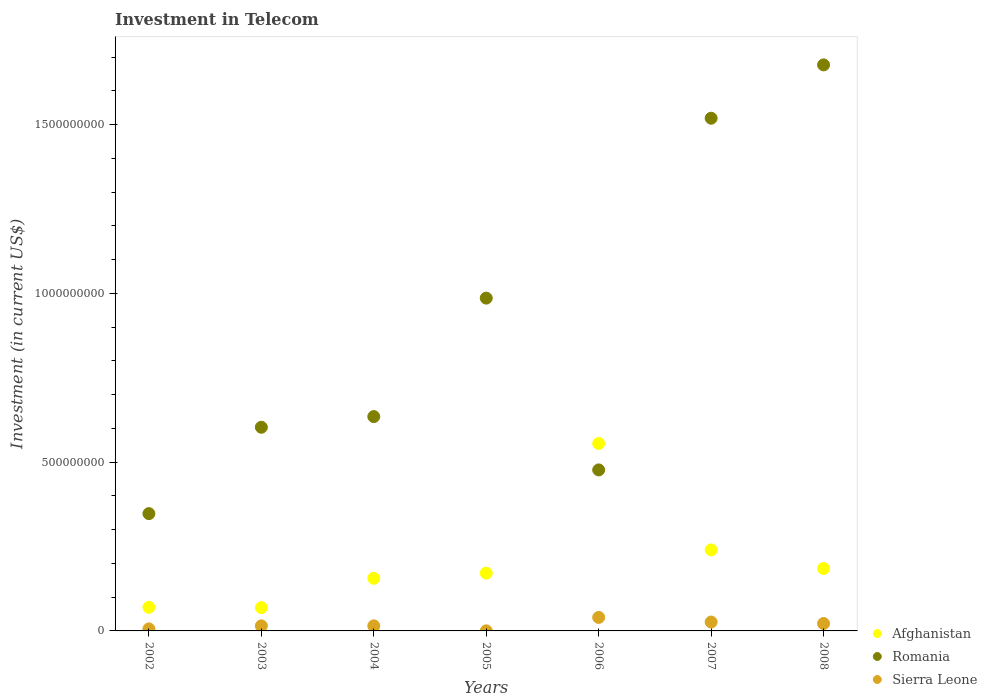Is the number of dotlines equal to the number of legend labels?
Your answer should be very brief. Yes. What is the amount invested in telecom in Sierra Leone in 2007?
Provide a succinct answer. 2.63e+07. Across all years, what is the maximum amount invested in telecom in Afghanistan?
Provide a succinct answer. 5.55e+08. In which year was the amount invested in telecom in Romania maximum?
Give a very brief answer. 2008. In which year was the amount invested in telecom in Afghanistan minimum?
Make the answer very short. 2003. What is the total amount invested in telecom in Romania in the graph?
Offer a terse response. 6.24e+09. What is the difference between the amount invested in telecom in Romania in 2004 and that in 2005?
Keep it short and to the point. -3.51e+08. What is the difference between the amount invested in telecom in Afghanistan in 2003 and the amount invested in telecom in Sierra Leone in 2005?
Keep it short and to the point. 6.88e+07. What is the average amount invested in telecom in Afghanistan per year?
Your answer should be compact. 2.07e+08. In the year 2006, what is the difference between the amount invested in telecom in Romania and amount invested in telecom in Sierra Leone?
Offer a terse response. 4.37e+08. What is the ratio of the amount invested in telecom in Sierra Leone in 2005 to that in 2008?
Your answer should be very brief. 0.01. Is the amount invested in telecom in Romania in 2006 less than that in 2008?
Your answer should be compact. Yes. Is the difference between the amount invested in telecom in Romania in 2002 and 2005 greater than the difference between the amount invested in telecom in Sierra Leone in 2002 and 2005?
Offer a very short reply. No. What is the difference between the highest and the second highest amount invested in telecom in Romania?
Provide a succinct answer. 1.58e+08. What is the difference between the highest and the lowest amount invested in telecom in Sierra Leone?
Ensure brevity in your answer.  3.98e+07. Is the amount invested in telecom in Romania strictly greater than the amount invested in telecom in Sierra Leone over the years?
Your answer should be very brief. Yes. Is the amount invested in telecom in Romania strictly less than the amount invested in telecom in Afghanistan over the years?
Keep it short and to the point. No. Are the values on the major ticks of Y-axis written in scientific E-notation?
Your response must be concise. No. Does the graph contain any zero values?
Offer a very short reply. No. Does the graph contain grids?
Provide a short and direct response. No. How many legend labels are there?
Make the answer very short. 3. How are the legend labels stacked?
Make the answer very short. Vertical. What is the title of the graph?
Offer a terse response. Investment in Telecom. Does "Swaziland" appear as one of the legend labels in the graph?
Your answer should be very brief. No. What is the label or title of the Y-axis?
Offer a very short reply. Investment (in current US$). What is the Investment (in current US$) of Afghanistan in 2002?
Provide a short and direct response. 7.00e+07. What is the Investment (in current US$) of Romania in 2002?
Offer a terse response. 3.48e+08. What is the Investment (in current US$) of Afghanistan in 2003?
Your response must be concise. 6.90e+07. What is the Investment (in current US$) in Romania in 2003?
Give a very brief answer. 6.03e+08. What is the Investment (in current US$) of Sierra Leone in 2003?
Offer a very short reply. 1.50e+07. What is the Investment (in current US$) in Afghanistan in 2004?
Give a very brief answer. 1.56e+08. What is the Investment (in current US$) of Romania in 2004?
Provide a succinct answer. 6.35e+08. What is the Investment (in current US$) in Sierra Leone in 2004?
Ensure brevity in your answer.  1.50e+07. What is the Investment (in current US$) of Afghanistan in 2005?
Your answer should be compact. 1.71e+08. What is the Investment (in current US$) of Romania in 2005?
Ensure brevity in your answer.  9.86e+08. What is the Investment (in current US$) in Afghanistan in 2006?
Provide a succinct answer. 5.55e+08. What is the Investment (in current US$) of Romania in 2006?
Make the answer very short. 4.77e+08. What is the Investment (in current US$) of Sierra Leone in 2006?
Make the answer very short. 4.00e+07. What is the Investment (in current US$) of Afghanistan in 2007?
Offer a very short reply. 2.40e+08. What is the Investment (in current US$) of Romania in 2007?
Make the answer very short. 1.52e+09. What is the Investment (in current US$) of Sierra Leone in 2007?
Ensure brevity in your answer.  2.63e+07. What is the Investment (in current US$) in Afghanistan in 2008?
Your answer should be very brief. 1.85e+08. What is the Investment (in current US$) of Romania in 2008?
Your answer should be very brief. 1.68e+09. What is the Investment (in current US$) in Sierra Leone in 2008?
Your answer should be compact. 2.19e+07. Across all years, what is the maximum Investment (in current US$) of Afghanistan?
Provide a short and direct response. 5.55e+08. Across all years, what is the maximum Investment (in current US$) in Romania?
Give a very brief answer. 1.68e+09. Across all years, what is the maximum Investment (in current US$) of Sierra Leone?
Ensure brevity in your answer.  4.00e+07. Across all years, what is the minimum Investment (in current US$) of Afghanistan?
Provide a succinct answer. 6.90e+07. Across all years, what is the minimum Investment (in current US$) of Romania?
Make the answer very short. 3.48e+08. Across all years, what is the minimum Investment (in current US$) of Sierra Leone?
Offer a very short reply. 2.50e+05. What is the total Investment (in current US$) in Afghanistan in the graph?
Keep it short and to the point. 1.45e+09. What is the total Investment (in current US$) in Romania in the graph?
Your answer should be very brief. 6.24e+09. What is the total Investment (in current US$) in Sierra Leone in the graph?
Keep it short and to the point. 1.24e+08. What is the difference between the Investment (in current US$) in Romania in 2002 and that in 2003?
Your response must be concise. -2.56e+08. What is the difference between the Investment (in current US$) of Sierra Leone in 2002 and that in 2003?
Keep it short and to the point. -9.00e+06. What is the difference between the Investment (in current US$) in Afghanistan in 2002 and that in 2004?
Keep it short and to the point. -8.60e+07. What is the difference between the Investment (in current US$) in Romania in 2002 and that in 2004?
Ensure brevity in your answer.  -2.88e+08. What is the difference between the Investment (in current US$) of Sierra Leone in 2002 and that in 2004?
Keep it short and to the point. -9.00e+06. What is the difference between the Investment (in current US$) in Afghanistan in 2002 and that in 2005?
Ensure brevity in your answer.  -1.01e+08. What is the difference between the Investment (in current US$) in Romania in 2002 and that in 2005?
Offer a very short reply. -6.38e+08. What is the difference between the Investment (in current US$) in Sierra Leone in 2002 and that in 2005?
Offer a terse response. 5.75e+06. What is the difference between the Investment (in current US$) in Afghanistan in 2002 and that in 2006?
Provide a short and direct response. -4.85e+08. What is the difference between the Investment (in current US$) of Romania in 2002 and that in 2006?
Provide a short and direct response. -1.30e+08. What is the difference between the Investment (in current US$) in Sierra Leone in 2002 and that in 2006?
Your answer should be very brief. -3.40e+07. What is the difference between the Investment (in current US$) in Afghanistan in 2002 and that in 2007?
Provide a succinct answer. -1.70e+08. What is the difference between the Investment (in current US$) in Romania in 2002 and that in 2007?
Provide a short and direct response. -1.17e+09. What is the difference between the Investment (in current US$) of Sierra Leone in 2002 and that in 2007?
Your response must be concise. -2.03e+07. What is the difference between the Investment (in current US$) of Afghanistan in 2002 and that in 2008?
Make the answer very short. -1.15e+08. What is the difference between the Investment (in current US$) of Romania in 2002 and that in 2008?
Keep it short and to the point. -1.33e+09. What is the difference between the Investment (in current US$) in Sierra Leone in 2002 and that in 2008?
Keep it short and to the point. -1.59e+07. What is the difference between the Investment (in current US$) of Afghanistan in 2003 and that in 2004?
Give a very brief answer. -8.70e+07. What is the difference between the Investment (in current US$) in Romania in 2003 and that in 2004?
Provide a succinct answer. -3.16e+07. What is the difference between the Investment (in current US$) in Afghanistan in 2003 and that in 2005?
Offer a very short reply. -1.02e+08. What is the difference between the Investment (in current US$) in Romania in 2003 and that in 2005?
Provide a short and direct response. -3.83e+08. What is the difference between the Investment (in current US$) of Sierra Leone in 2003 and that in 2005?
Make the answer very short. 1.48e+07. What is the difference between the Investment (in current US$) of Afghanistan in 2003 and that in 2006?
Provide a succinct answer. -4.86e+08. What is the difference between the Investment (in current US$) of Romania in 2003 and that in 2006?
Offer a very short reply. 1.26e+08. What is the difference between the Investment (in current US$) of Sierra Leone in 2003 and that in 2006?
Provide a short and direct response. -2.50e+07. What is the difference between the Investment (in current US$) of Afghanistan in 2003 and that in 2007?
Provide a succinct answer. -1.71e+08. What is the difference between the Investment (in current US$) of Romania in 2003 and that in 2007?
Keep it short and to the point. -9.16e+08. What is the difference between the Investment (in current US$) in Sierra Leone in 2003 and that in 2007?
Ensure brevity in your answer.  -1.13e+07. What is the difference between the Investment (in current US$) of Afghanistan in 2003 and that in 2008?
Provide a short and direct response. -1.16e+08. What is the difference between the Investment (in current US$) in Romania in 2003 and that in 2008?
Your answer should be compact. -1.07e+09. What is the difference between the Investment (in current US$) in Sierra Leone in 2003 and that in 2008?
Provide a succinct answer. -6.90e+06. What is the difference between the Investment (in current US$) of Afghanistan in 2004 and that in 2005?
Provide a short and direct response. -1.51e+07. What is the difference between the Investment (in current US$) in Romania in 2004 and that in 2005?
Keep it short and to the point. -3.51e+08. What is the difference between the Investment (in current US$) in Sierra Leone in 2004 and that in 2005?
Give a very brief answer. 1.48e+07. What is the difference between the Investment (in current US$) of Afghanistan in 2004 and that in 2006?
Make the answer very short. -3.99e+08. What is the difference between the Investment (in current US$) of Romania in 2004 and that in 2006?
Your response must be concise. 1.58e+08. What is the difference between the Investment (in current US$) in Sierra Leone in 2004 and that in 2006?
Your answer should be very brief. -2.50e+07. What is the difference between the Investment (in current US$) in Afghanistan in 2004 and that in 2007?
Ensure brevity in your answer.  -8.40e+07. What is the difference between the Investment (in current US$) of Romania in 2004 and that in 2007?
Ensure brevity in your answer.  -8.84e+08. What is the difference between the Investment (in current US$) of Sierra Leone in 2004 and that in 2007?
Offer a terse response. -1.13e+07. What is the difference between the Investment (in current US$) in Afghanistan in 2004 and that in 2008?
Give a very brief answer. -2.90e+07. What is the difference between the Investment (in current US$) in Romania in 2004 and that in 2008?
Ensure brevity in your answer.  -1.04e+09. What is the difference between the Investment (in current US$) in Sierra Leone in 2004 and that in 2008?
Your answer should be very brief. -6.90e+06. What is the difference between the Investment (in current US$) in Afghanistan in 2005 and that in 2006?
Your answer should be compact. -3.84e+08. What is the difference between the Investment (in current US$) of Romania in 2005 and that in 2006?
Ensure brevity in your answer.  5.09e+08. What is the difference between the Investment (in current US$) in Sierra Leone in 2005 and that in 2006?
Keep it short and to the point. -3.98e+07. What is the difference between the Investment (in current US$) in Afghanistan in 2005 and that in 2007?
Give a very brief answer. -6.89e+07. What is the difference between the Investment (in current US$) of Romania in 2005 and that in 2007?
Keep it short and to the point. -5.33e+08. What is the difference between the Investment (in current US$) in Sierra Leone in 2005 and that in 2007?
Keep it short and to the point. -2.60e+07. What is the difference between the Investment (in current US$) in Afghanistan in 2005 and that in 2008?
Your response must be concise. -1.39e+07. What is the difference between the Investment (in current US$) of Romania in 2005 and that in 2008?
Make the answer very short. -6.91e+08. What is the difference between the Investment (in current US$) in Sierra Leone in 2005 and that in 2008?
Provide a succinct answer. -2.16e+07. What is the difference between the Investment (in current US$) in Afghanistan in 2006 and that in 2007?
Keep it short and to the point. 3.15e+08. What is the difference between the Investment (in current US$) of Romania in 2006 and that in 2007?
Offer a very short reply. -1.04e+09. What is the difference between the Investment (in current US$) in Sierra Leone in 2006 and that in 2007?
Your response must be concise. 1.37e+07. What is the difference between the Investment (in current US$) of Afghanistan in 2006 and that in 2008?
Offer a very short reply. 3.70e+08. What is the difference between the Investment (in current US$) in Romania in 2006 and that in 2008?
Offer a terse response. -1.20e+09. What is the difference between the Investment (in current US$) in Sierra Leone in 2006 and that in 2008?
Give a very brief answer. 1.81e+07. What is the difference between the Investment (in current US$) of Afghanistan in 2007 and that in 2008?
Your response must be concise. 5.50e+07. What is the difference between the Investment (in current US$) of Romania in 2007 and that in 2008?
Offer a very short reply. -1.58e+08. What is the difference between the Investment (in current US$) of Sierra Leone in 2007 and that in 2008?
Give a very brief answer. 4.40e+06. What is the difference between the Investment (in current US$) in Afghanistan in 2002 and the Investment (in current US$) in Romania in 2003?
Make the answer very short. -5.33e+08. What is the difference between the Investment (in current US$) in Afghanistan in 2002 and the Investment (in current US$) in Sierra Leone in 2003?
Offer a very short reply. 5.50e+07. What is the difference between the Investment (in current US$) in Romania in 2002 and the Investment (in current US$) in Sierra Leone in 2003?
Provide a short and direct response. 3.32e+08. What is the difference between the Investment (in current US$) in Afghanistan in 2002 and the Investment (in current US$) in Romania in 2004?
Your answer should be very brief. -5.65e+08. What is the difference between the Investment (in current US$) in Afghanistan in 2002 and the Investment (in current US$) in Sierra Leone in 2004?
Offer a very short reply. 5.50e+07. What is the difference between the Investment (in current US$) in Romania in 2002 and the Investment (in current US$) in Sierra Leone in 2004?
Offer a terse response. 3.32e+08. What is the difference between the Investment (in current US$) in Afghanistan in 2002 and the Investment (in current US$) in Romania in 2005?
Your answer should be compact. -9.16e+08. What is the difference between the Investment (in current US$) of Afghanistan in 2002 and the Investment (in current US$) of Sierra Leone in 2005?
Make the answer very short. 6.98e+07. What is the difference between the Investment (in current US$) of Romania in 2002 and the Investment (in current US$) of Sierra Leone in 2005?
Offer a very short reply. 3.47e+08. What is the difference between the Investment (in current US$) in Afghanistan in 2002 and the Investment (in current US$) in Romania in 2006?
Ensure brevity in your answer.  -4.07e+08. What is the difference between the Investment (in current US$) in Afghanistan in 2002 and the Investment (in current US$) in Sierra Leone in 2006?
Your answer should be very brief. 3.00e+07. What is the difference between the Investment (in current US$) in Romania in 2002 and the Investment (in current US$) in Sierra Leone in 2006?
Your answer should be very brief. 3.08e+08. What is the difference between the Investment (in current US$) of Afghanistan in 2002 and the Investment (in current US$) of Romania in 2007?
Ensure brevity in your answer.  -1.45e+09. What is the difference between the Investment (in current US$) in Afghanistan in 2002 and the Investment (in current US$) in Sierra Leone in 2007?
Provide a short and direct response. 4.37e+07. What is the difference between the Investment (in current US$) in Romania in 2002 and the Investment (in current US$) in Sierra Leone in 2007?
Provide a short and direct response. 3.21e+08. What is the difference between the Investment (in current US$) in Afghanistan in 2002 and the Investment (in current US$) in Romania in 2008?
Your response must be concise. -1.61e+09. What is the difference between the Investment (in current US$) in Afghanistan in 2002 and the Investment (in current US$) in Sierra Leone in 2008?
Give a very brief answer. 4.81e+07. What is the difference between the Investment (in current US$) of Romania in 2002 and the Investment (in current US$) of Sierra Leone in 2008?
Provide a succinct answer. 3.26e+08. What is the difference between the Investment (in current US$) in Afghanistan in 2003 and the Investment (in current US$) in Romania in 2004?
Your response must be concise. -5.66e+08. What is the difference between the Investment (in current US$) in Afghanistan in 2003 and the Investment (in current US$) in Sierra Leone in 2004?
Keep it short and to the point. 5.40e+07. What is the difference between the Investment (in current US$) in Romania in 2003 and the Investment (in current US$) in Sierra Leone in 2004?
Your answer should be compact. 5.88e+08. What is the difference between the Investment (in current US$) in Afghanistan in 2003 and the Investment (in current US$) in Romania in 2005?
Make the answer very short. -9.17e+08. What is the difference between the Investment (in current US$) in Afghanistan in 2003 and the Investment (in current US$) in Sierra Leone in 2005?
Ensure brevity in your answer.  6.88e+07. What is the difference between the Investment (in current US$) of Romania in 2003 and the Investment (in current US$) of Sierra Leone in 2005?
Provide a succinct answer. 6.03e+08. What is the difference between the Investment (in current US$) of Afghanistan in 2003 and the Investment (in current US$) of Romania in 2006?
Offer a very short reply. -4.08e+08. What is the difference between the Investment (in current US$) of Afghanistan in 2003 and the Investment (in current US$) of Sierra Leone in 2006?
Your response must be concise. 2.90e+07. What is the difference between the Investment (in current US$) of Romania in 2003 and the Investment (in current US$) of Sierra Leone in 2006?
Make the answer very short. 5.63e+08. What is the difference between the Investment (in current US$) of Afghanistan in 2003 and the Investment (in current US$) of Romania in 2007?
Provide a short and direct response. -1.45e+09. What is the difference between the Investment (in current US$) of Afghanistan in 2003 and the Investment (in current US$) of Sierra Leone in 2007?
Your answer should be compact. 4.27e+07. What is the difference between the Investment (in current US$) of Romania in 2003 and the Investment (in current US$) of Sierra Leone in 2007?
Your response must be concise. 5.77e+08. What is the difference between the Investment (in current US$) of Afghanistan in 2003 and the Investment (in current US$) of Romania in 2008?
Offer a very short reply. -1.61e+09. What is the difference between the Investment (in current US$) in Afghanistan in 2003 and the Investment (in current US$) in Sierra Leone in 2008?
Offer a very short reply. 4.71e+07. What is the difference between the Investment (in current US$) of Romania in 2003 and the Investment (in current US$) of Sierra Leone in 2008?
Your answer should be very brief. 5.82e+08. What is the difference between the Investment (in current US$) in Afghanistan in 2004 and the Investment (in current US$) in Romania in 2005?
Your answer should be very brief. -8.30e+08. What is the difference between the Investment (in current US$) in Afghanistan in 2004 and the Investment (in current US$) in Sierra Leone in 2005?
Offer a very short reply. 1.56e+08. What is the difference between the Investment (in current US$) in Romania in 2004 and the Investment (in current US$) in Sierra Leone in 2005?
Make the answer very short. 6.35e+08. What is the difference between the Investment (in current US$) of Afghanistan in 2004 and the Investment (in current US$) of Romania in 2006?
Offer a very short reply. -3.21e+08. What is the difference between the Investment (in current US$) in Afghanistan in 2004 and the Investment (in current US$) in Sierra Leone in 2006?
Your answer should be compact. 1.16e+08. What is the difference between the Investment (in current US$) in Romania in 2004 and the Investment (in current US$) in Sierra Leone in 2006?
Offer a very short reply. 5.95e+08. What is the difference between the Investment (in current US$) of Afghanistan in 2004 and the Investment (in current US$) of Romania in 2007?
Your response must be concise. -1.36e+09. What is the difference between the Investment (in current US$) of Afghanistan in 2004 and the Investment (in current US$) of Sierra Leone in 2007?
Make the answer very short. 1.30e+08. What is the difference between the Investment (in current US$) of Romania in 2004 and the Investment (in current US$) of Sierra Leone in 2007?
Your answer should be compact. 6.09e+08. What is the difference between the Investment (in current US$) in Afghanistan in 2004 and the Investment (in current US$) in Romania in 2008?
Make the answer very short. -1.52e+09. What is the difference between the Investment (in current US$) of Afghanistan in 2004 and the Investment (in current US$) of Sierra Leone in 2008?
Offer a very short reply. 1.34e+08. What is the difference between the Investment (in current US$) of Romania in 2004 and the Investment (in current US$) of Sierra Leone in 2008?
Keep it short and to the point. 6.13e+08. What is the difference between the Investment (in current US$) of Afghanistan in 2005 and the Investment (in current US$) of Romania in 2006?
Ensure brevity in your answer.  -3.06e+08. What is the difference between the Investment (in current US$) in Afghanistan in 2005 and the Investment (in current US$) in Sierra Leone in 2006?
Provide a succinct answer. 1.31e+08. What is the difference between the Investment (in current US$) of Romania in 2005 and the Investment (in current US$) of Sierra Leone in 2006?
Provide a short and direct response. 9.46e+08. What is the difference between the Investment (in current US$) in Afghanistan in 2005 and the Investment (in current US$) in Romania in 2007?
Offer a terse response. -1.35e+09. What is the difference between the Investment (in current US$) in Afghanistan in 2005 and the Investment (in current US$) in Sierra Leone in 2007?
Provide a short and direct response. 1.45e+08. What is the difference between the Investment (in current US$) of Romania in 2005 and the Investment (in current US$) of Sierra Leone in 2007?
Offer a very short reply. 9.60e+08. What is the difference between the Investment (in current US$) of Afghanistan in 2005 and the Investment (in current US$) of Romania in 2008?
Offer a terse response. -1.51e+09. What is the difference between the Investment (in current US$) of Afghanistan in 2005 and the Investment (in current US$) of Sierra Leone in 2008?
Offer a very short reply. 1.49e+08. What is the difference between the Investment (in current US$) in Romania in 2005 and the Investment (in current US$) in Sierra Leone in 2008?
Keep it short and to the point. 9.64e+08. What is the difference between the Investment (in current US$) of Afghanistan in 2006 and the Investment (in current US$) of Romania in 2007?
Offer a very short reply. -9.64e+08. What is the difference between the Investment (in current US$) of Afghanistan in 2006 and the Investment (in current US$) of Sierra Leone in 2007?
Offer a terse response. 5.29e+08. What is the difference between the Investment (in current US$) in Romania in 2006 and the Investment (in current US$) in Sierra Leone in 2007?
Your response must be concise. 4.51e+08. What is the difference between the Investment (in current US$) of Afghanistan in 2006 and the Investment (in current US$) of Romania in 2008?
Your response must be concise. -1.12e+09. What is the difference between the Investment (in current US$) of Afghanistan in 2006 and the Investment (in current US$) of Sierra Leone in 2008?
Ensure brevity in your answer.  5.34e+08. What is the difference between the Investment (in current US$) of Romania in 2006 and the Investment (in current US$) of Sierra Leone in 2008?
Provide a short and direct response. 4.55e+08. What is the difference between the Investment (in current US$) in Afghanistan in 2007 and the Investment (in current US$) in Romania in 2008?
Make the answer very short. -1.44e+09. What is the difference between the Investment (in current US$) in Afghanistan in 2007 and the Investment (in current US$) in Sierra Leone in 2008?
Provide a short and direct response. 2.18e+08. What is the difference between the Investment (in current US$) in Romania in 2007 and the Investment (in current US$) in Sierra Leone in 2008?
Your answer should be compact. 1.50e+09. What is the average Investment (in current US$) of Afghanistan per year?
Provide a succinct answer. 2.07e+08. What is the average Investment (in current US$) in Romania per year?
Give a very brief answer. 8.92e+08. What is the average Investment (in current US$) in Sierra Leone per year?
Ensure brevity in your answer.  1.78e+07. In the year 2002, what is the difference between the Investment (in current US$) of Afghanistan and Investment (in current US$) of Romania?
Your response must be concise. -2.78e+08. In the year 2002, what is the difference between the Investment (in current US$) of Afghanistan and Investment (in current US$) of Sierra Leone?
Make the answer very short. 6.40e+07. In the year 2002, what is the difference between the Investment (in current US$) in Romania and Investment (in current US$) in Sierra Leone?
Make the answer very short. 3.42e+08. In the year 2003, what is the difference between the Investment (in current US$) of Afghanistan and Investment (in current US$) of Romania?
Provide a short and direct response. -5.34e+08. In the year 2003, what is the difference between the Investment (in current US$) in Afghanistan and Investment (in current US$) in Sierra Leone?
Offer a very short reply. 5.40e+07. In the year 2003, what is the difference between the Investment (in current US$) of Romania and Investment (in current US$) of Sierra Leone?
Provide a succinct answer. 5.88e+08. In the year 2004, what is the difference between the Investment (in current US$) in Afghanistan and Investment (in current US$) in Romania?
Keep it short and to the point. -4.79e+08. In the year 2004, what is the difference between the Investment (in current US$) of Afghanistan and Investment (in current US$) of Sierra Leone?
Offer a very short reply. 1.41e+08. In the year 2004, what is the difference between the Investment (in current US$) of Romania and Investment (in current US$) of Sierra Leone?
Give a very brief answer. 6.20e+08. In the year 2005, what is the difference between the Investment (in current US$) of Afghanistan and Investment (in current US$) of Romania?
Give a very brief answer. -8.15e+08. In the year 2005, what is the difference between the Investment (in current US$) of Afghanistan and Investment (in current US$) of Sierra Leone?
Provide a succinct answer. 1.71e+08. In the year 2005, what is the difference between the Investment (in current US$) of Romania and Investment (in current US$) of Sierra Leone?
Offer a terse response. 9.86e+08. In the year 2006, what is the difference between the Investment (in current US$) of Afghanistan and Investment (in current US$) of Romania?
Keep it short and to the point. 7.84e+07. In the year 2006, what is the difference between the Investment (in current US$) in Afghanistan and Investment (in current US$) in Sierra Leone?
Ensure brevity in your answer.  5.15e+08. In the year 2006, what is the difference between the Investment (in current US$) of Romania and Investment (in current US$) of Sierra Leone?
Your answer should be very brief. 4.37e+08. In the year 2007, what is the difference between the Investment (in current US$) of Afghanistan and Investment (in current US$) of Romania?
Ensure brevity in your answer.  -1.28e+09. In the year 2007, what is the difference between the Investment (in current US$) of Afghanistan and Investment (in current US$) of Sierra Leone?
Your response must be concise. 2.14e+08. In the year 2007, what is the difference between the Investment (in current US$) of Romania and Investment (in current US$) of Sierra Leone?
Your answer should be compact. 1.49e+09. In the year 2008, what is the difference between the Investment (in current US$) of Afghanistan and Investment (in current US$) of Romania?
Ensure brevity in your answer.  -1.49e+09. In the year 2008, what is the difference between the Investment (in current US$) of Afghanistan and Investment (in current US$) of Sierra Leone?
Offer a very short reply. 1.63e+08. In the year 2008, what is the difference between the Investment (in current US$) of Romania and Investment (in current US$) of Sierra Leone?
Offer a very short reply. 1.66e+09. What is the ratio of the Investment (in current US$) of Afghanistan in 2002 to that in 2003?
Provide a short and direct response. 1.01. What is the ratio of the Investment (in current US$) of Romania in 2002 to that in 2003?
Give a very brief answer. 0.58. What is the ratio of the Investment (in current US$) in Afghanistan in 2002 to that in 2004?
Provide a short and direct response. 0.45. What is the ratio of the Investment (in current US$) in Romania in 2002 to that in 2004?
Offer a very short reply. 0.55. What is the ratio of the Investment (in current US$) of Sierra Leone in 2002 to that in 2004?
Offer a very short reply. 0.4. What is the ratio of the Investment (in current US$) in Afghanistan in 2002 to that in 2005?
Your answer should be very brief. 0.41. What is the ratio of the Investment (in current US$) in Romania in 2002 to that in 2005?
Your answer should be compact. 0.35. What is the ratio of the Investment (in current US$) in Sierra Leone in 2002 to that in 2005?
Ensure brevity in your answer.  24. What is the ratio of the Investment (in current US$) in Afghanistan in 2002 to that in 2006?
Your answer should be very brief. 0.13. What is the ratio of the Investment (in current US$) in Romania in 2002 to that in 2006?
Offer a terse response. 0.73. What is the ratio of the Investment (in current US$) in Sierra Leone in 2002 to that in 2006?
Provide a short and direct response. 0.15. What is the ratio of the Investment (in current US$) in Afghanistan in 2002 to that in 2007?
Your response must be concise. 0.29. What is the ratio of the Investment (in current US$) of Romania in 2002 to that in 2007?
Your response must be concise. 0.23. What is the ratio of the Investment (in current US$) of Sierra Leone in 2002 to that in 2007?
Offer a terse response. 0.23. What is the ratio of the Investment (in current US$) in Afghanistan in 2002 to that in 2008?
Your answer should be compact. 0.38. What is the ratio of the Investment (in current US$) of Romania in 2002 to that in 2008?
Your answer should be very brief. 0.21. What is the ratio of the Investment (in current US$) of Sierra Leone in 2002 to that in 2008?
Your answer should be compact. 0.27. What is the ratio of the Investment (in current US$) in Afghanistan in 2003 to that in 2004?
Offer a terse response. 0.44. What is the ratio of the Investment (in current US$) in Romania in 2003 to that in 2004?
Your response must be concise. 0.95. What is the ratio of the Investment (in current US$) of Sierra Leone in 2003 to that in 2004?
Offer a very short reply. 1. What is the ratio of the Investment (in current US$) of Afghanistan in 2003 to that in 2005?
Offer a very short reply. 0.4. What is the ratio of the Investment (in current US$) of Romania in 2003 to that in 2005?
Your answer should be very brief. 0.61. What is the ratio of the Investment (in current US$) of Afghanistan in 2003 to that in 2006?
Provide a short and direct response. 0.12. What is the ratio of the Investment (in current US$) in Romania in 2003 to that in 2006?
Offer a very short reply. 1.26. What is the ratio of the Investment (in current US$) in Afghanistan in 2003 to that in 2007?
Keep it short and to the point. 0.29. What is the ratio of the Investment (in current US$) in Romania in 2003 to that in 2007?
Keep it short and to the point. 0.4. What is the ratio of the Investment (in current US$) in Sierra Leone in 2003 to that in 2007?
Offer a very short reply. 0.57. What is the ratio of the Investment (in current US$) of Afghanistan in 2003 to that in 2008?
Your response must be concise. 0.37. What is the ratio of the Investment (in current US$) of Romania in 2003 to that in 2008?
Your response must be concise. 0.36. What is the ratio of the Investment (in current US$) of Sierra Leone in 2003 to that in 2008?
Ensure brevity in your answer.  0.68. What is the ratio of the Investment (in current US$) in Afghanistan in 2004 to that in 2005?
Keep it short and to the point. 0.91. What is the ratio of the Investment (in current US$) in Romania in 2004 to that in 2005?
Ensure brevity in your answer.  0.64. What is the ratio of the Investment (in current US$) in Sierra Leone in 2004 to that in 2005?
Provide a succinct answer. 60. What is the ratio of the Investment (in current US$) of Afghanistan in 2004 to that in 2006?
Give a very brief answer. 0.28. What is the ratio of the Investment (in current US$) in Romania in 2004 to that in 2006?
Your response must be concise. 1.33. What is the ratio of the Investment (in current US$) in Sierra Leone in 2004 to that in 2006?
Provide a succinct answer. 0.38. What is the ratio of the Investment (in current US$) of Afghanistan in 2004 to that in 2007?
Your answer should be compact. 0.65. What is the ratio of the Investment (in current US$) of Romania in 2004 to that in 2007?
Offer a very short reply. 0.42. What is the ratio of the Investment (in current US$) in Sierra Leone in 2004 to that in 2007?
Ensure brevity in your answer.  0.57. What is the ratio of the Investment (in current US$) of Afghanistan in 2004 to that in 2008?
Ensure brevity in your answer.  0.84. What is the ratio of the Investment (in current US$) of Romania in 2004 to that in 2008?
Provide a succinct answer. 0.38. What is the ratio of the Investment (in current US$) of Sierra Leone in 2004 to that in 2008?
Your response must be concise. 0.68. What is the ratio of the Investment (in current US$) of Afghanistan in 2005 to that in 2006?
Offer a terse response. 0.31. What is the ratio of the Investment (in current US$) of Romania in 2005 to that in 2006?
Keep it short and to the point. 2.07. What is the ratio of the Investment (in current US$) of Sierra Leone in 2005 to that in 2006?
Your answer should be very brief. 0.01. What is the ratio of the Investment (in current US$) in Afghanistan in 2005 to that in 2007?
Ensure brevity in your answer.  0.71. What is the ratio of the Investment (in current US$) in Romania in 2005 to that in 2007?
Your answer should be very brief. 0.65. What is the ratio of the Investment (in current US$) of Sierra Leone in 2005 to that in 2007?
Provide a succinct answer. 0.01. What is the ratio of the Investment (in current US$) of Afghanistan in 2005 to that in 2008?
Provide a succinct answer. 0.92. What is the ratio of the Investment (in current US$) of Romania in 2005 to that in 2008?
Keep it short and to the point. 0.59. What is the ratio of the Investment (in current US$) in Sierra Leone in 2005 to that in 2008?
Your response must be concise. 0.01. What is the ratio of the Investment (in current US$) in Afghanistan in 2006 to that in 2007?
Offer a very short reply. 2.31. What is the ratio of the Investment (in current US$) in Romania in 2006 to that in 2007?
Offer a very short reply. 0.31. What is the ratio of the Investment (in current US$) in Sierra Leone in 2006 to that in 2007?
Give a very brief answer. 1.52. What is the ratio of the Investment (in current US$) of Afghanistan in 2006 to that in 2008?
Ensure brevity in your answer.  3. What is the ratio of the Investment (in current US$) in Romania in 2006 to that in 2008?
Your answer should be very brief. 0.28. What is the ratio of the Investment (in current US$) of Sierra Leone in 2006 to that in 2008?
Your answer should be compact. 1.83. What is the ratio of the Investment (in current US$) of Afghanistan in 2007 to that in 2008?
Your response must be concise. 1.3. What is the ratio of the Investment (in current US$) of Romania in 2007 to that in 2008?
Offer a terse response. 0.91. What is the ratio of the Investment (in current US$) of Sierra Leone in 2007 to that in 2008?
Your response must be concise. 1.2. What is the difference between the highest and the second highest Investment (in current US$) of Afghanistan?
Provide a short and direct response. 3.15e+08. What is the difference between the highest and the second highest Investment (in current US$) of Romania?
Offer a very short reply. 1.58e+08. What is the difference between the highest and the second highest Investment (in current US$) in Sierra Leone?
Make the answer very short. 1.37e+07. What is the difference between the highest and the lowest Investment (in current US$) of Afghanistan?
Give a very brief answer. 4.86e+08. What is the difference between the highest and the lowest Investment (in current US$) of Romania?
Offer a terse response. 1.33e+09. What is the difference between the highest and the lowest Investment (in current US$) in Sierra Leone?
Your answer should be compact. 3.98e+07. 